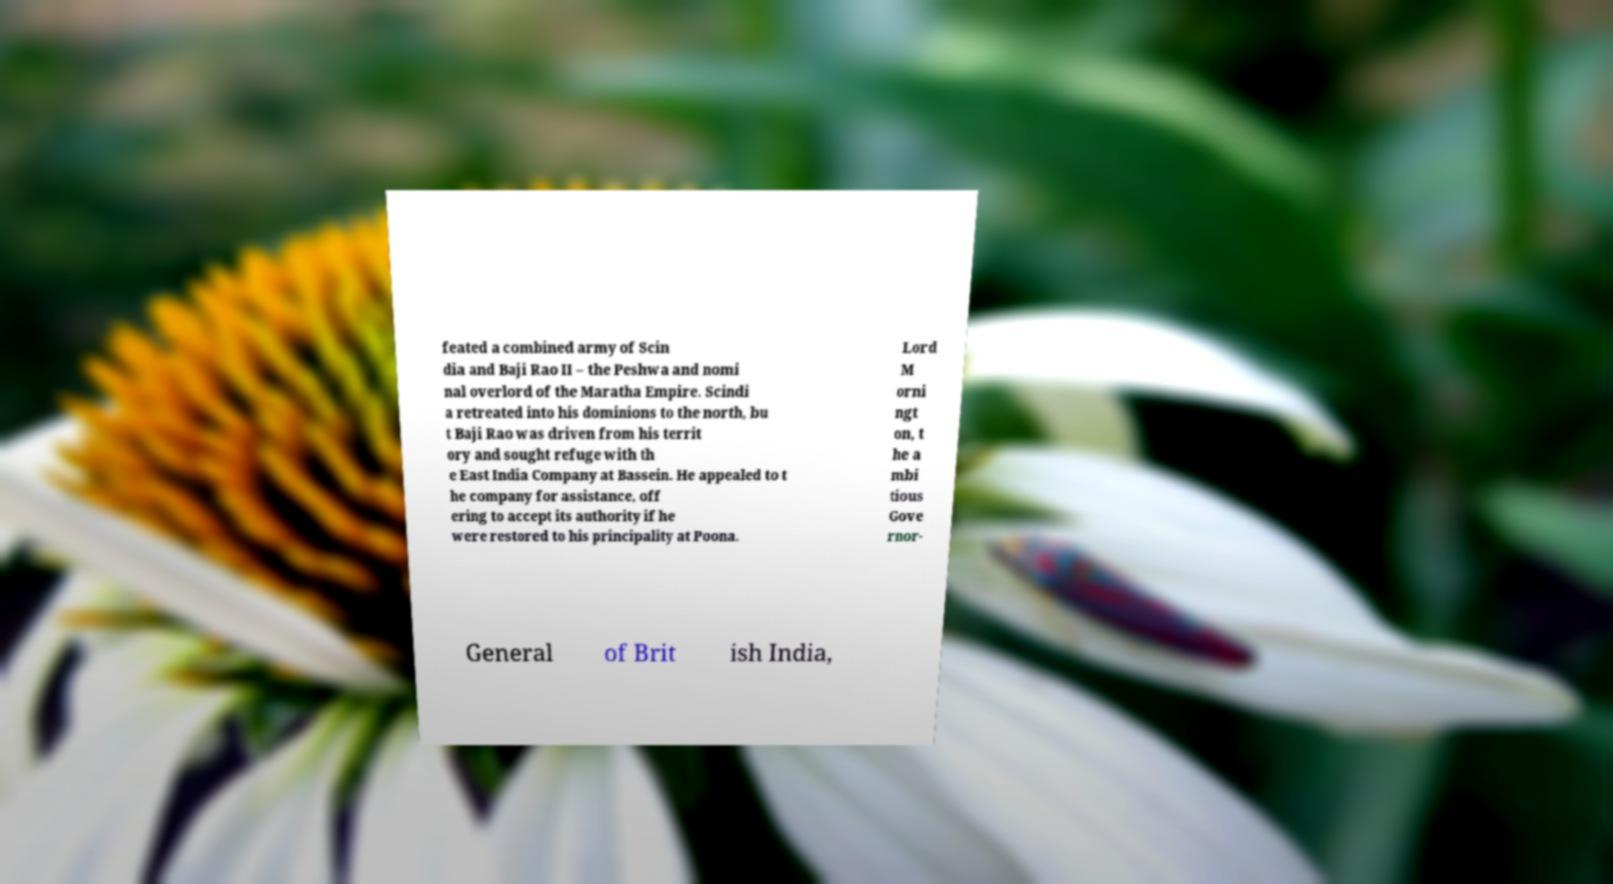What messages or text are displayed in this image? I need them in a readable, typed format. feated a combined army of Scin dia and Baji Rao II – the Peshwa and nomi nal overlord of the Maratha Empire. Scindi a retreated into his dominions to the north, bu t Baji Rao was driven from his territ ory and sought refuge with th e East India Company at Bassein. He appealed to t he company for assistance, off ering to accept its authority if he were restored to his principality at Poona. Lord M orni ngt on, t he a mbi tious Gove rnor- General of Brit ish India, 